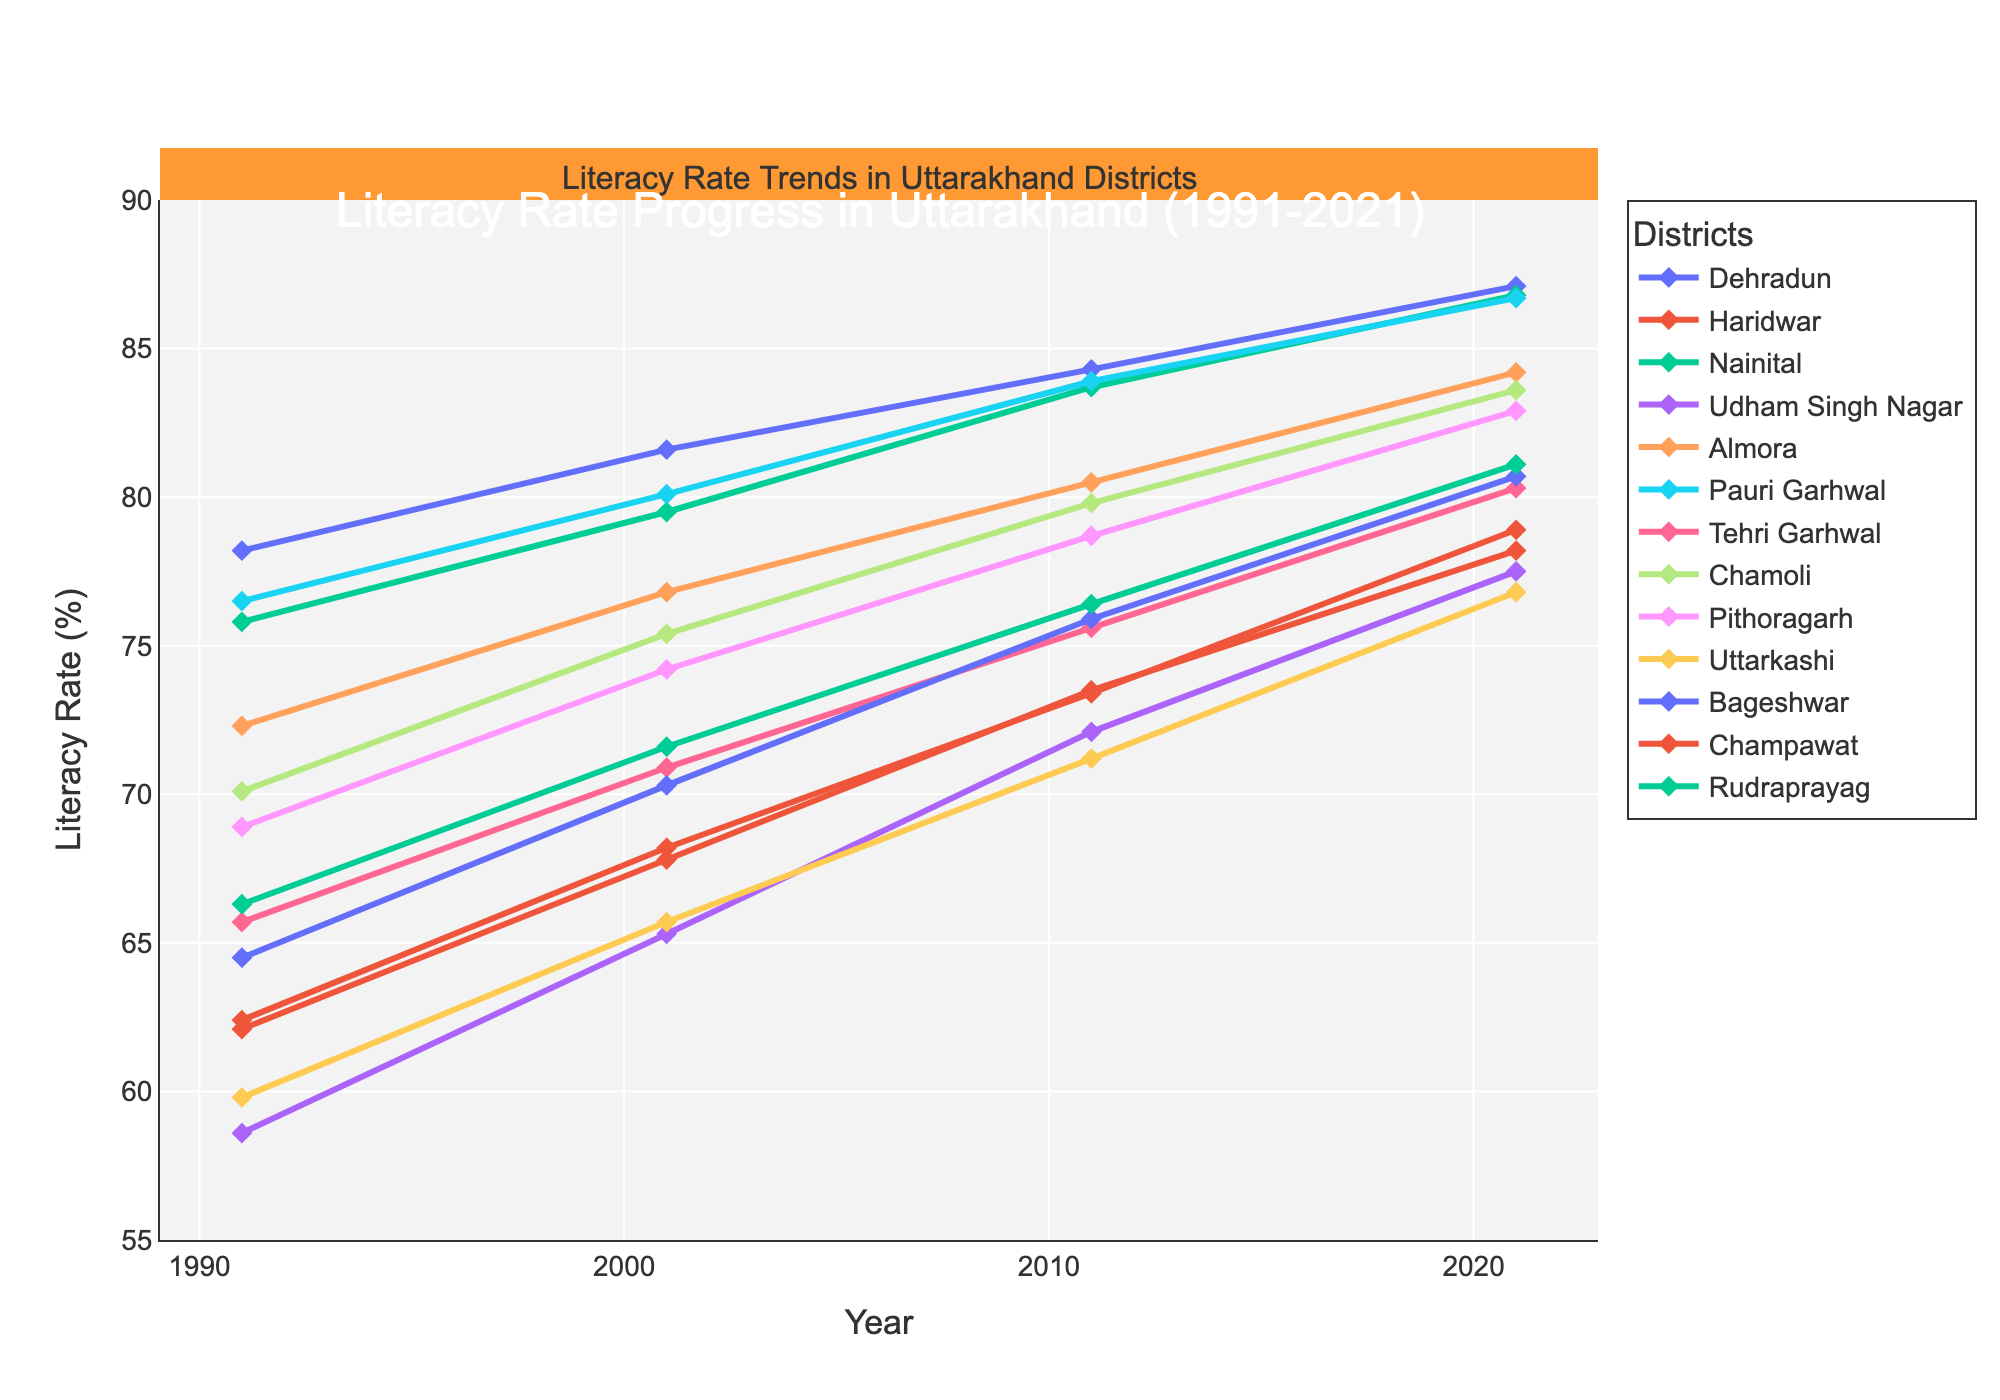Which district had the highest literacy rate in 2021? By looking at the endpoints of each line for 2021, Dehradun has the highest position at 87.1%.
Answer: Dehradun Which district had the lowest literacy rate in 1991? By examining the starting points of each line for 1991, Udham Singh Nagar has the lowest position at 58.6%.
Answer: Udham Singh Nagar How much did the literacy rate in Haridwar increase from 1991 to 2021? Subtract the 1991 rate from the 2021 rate for Haridwar: 78.9% - 62.4% = 16.5%.
Answer: 16.5% Which districts had a literacy rate above 80% in 2001? By evaluating the data points in 2001, Dehradun, Nainital, Almora, Pauri Garhwal, and Chamoli have rates above 80%.
Answer: Dehradun, Nainital, Almora, Pauri Garhwal, Chamoli Between Nainital and Pithoragarh, which district had a higher literacy rate in 2011? By tracing the points for 2011, Nainital had a literacy rate of 83.7% while Pithoragarh had 78.7%.
Answer: Nainital Which district showed the greatest increase in literacy rate from 1991 to 2021? Calculate the difference between 1991 and 2021 for each district and find the maximum value. Udham Singh Nagar increased from 58.6% to 77.5%, a rise of 18.9%.
Answer: Udham Singh Nagar What is the average literacy rate of Pauri Garhwal across all years? Sum Pauri Garhwal's literacy rates: (76.5 + 80.1 + 83.9 + 86.7) = 327.2; then divide by 4: 327.2 / 4 = 81.8%.
Answer: 81.8% Which district's literacy rate remained below 70% until 2021? Check whether any district's rate stayed below 70% in all years until 2021. Uttarkashi was below 70% in 1991 and reached above 70% only after 2001.
Answer: Uttarkashi Compare the literacy rates of Chamoli and Tehri Garhwal in 2001. Which was higher? By referring to the 2001 data points, Chamoli had a literacy rate of 75.4% while Tehri Garhwal had 70.9%.
Answer: Chamoli What was the difference in literacy rate between Bageshwar and Champawat in 2021? Subtract the literacy rate of Champawat from Bageshwar for 2021: 80.7% - 78.2% = 2.5%.
Answer: 2.5% 